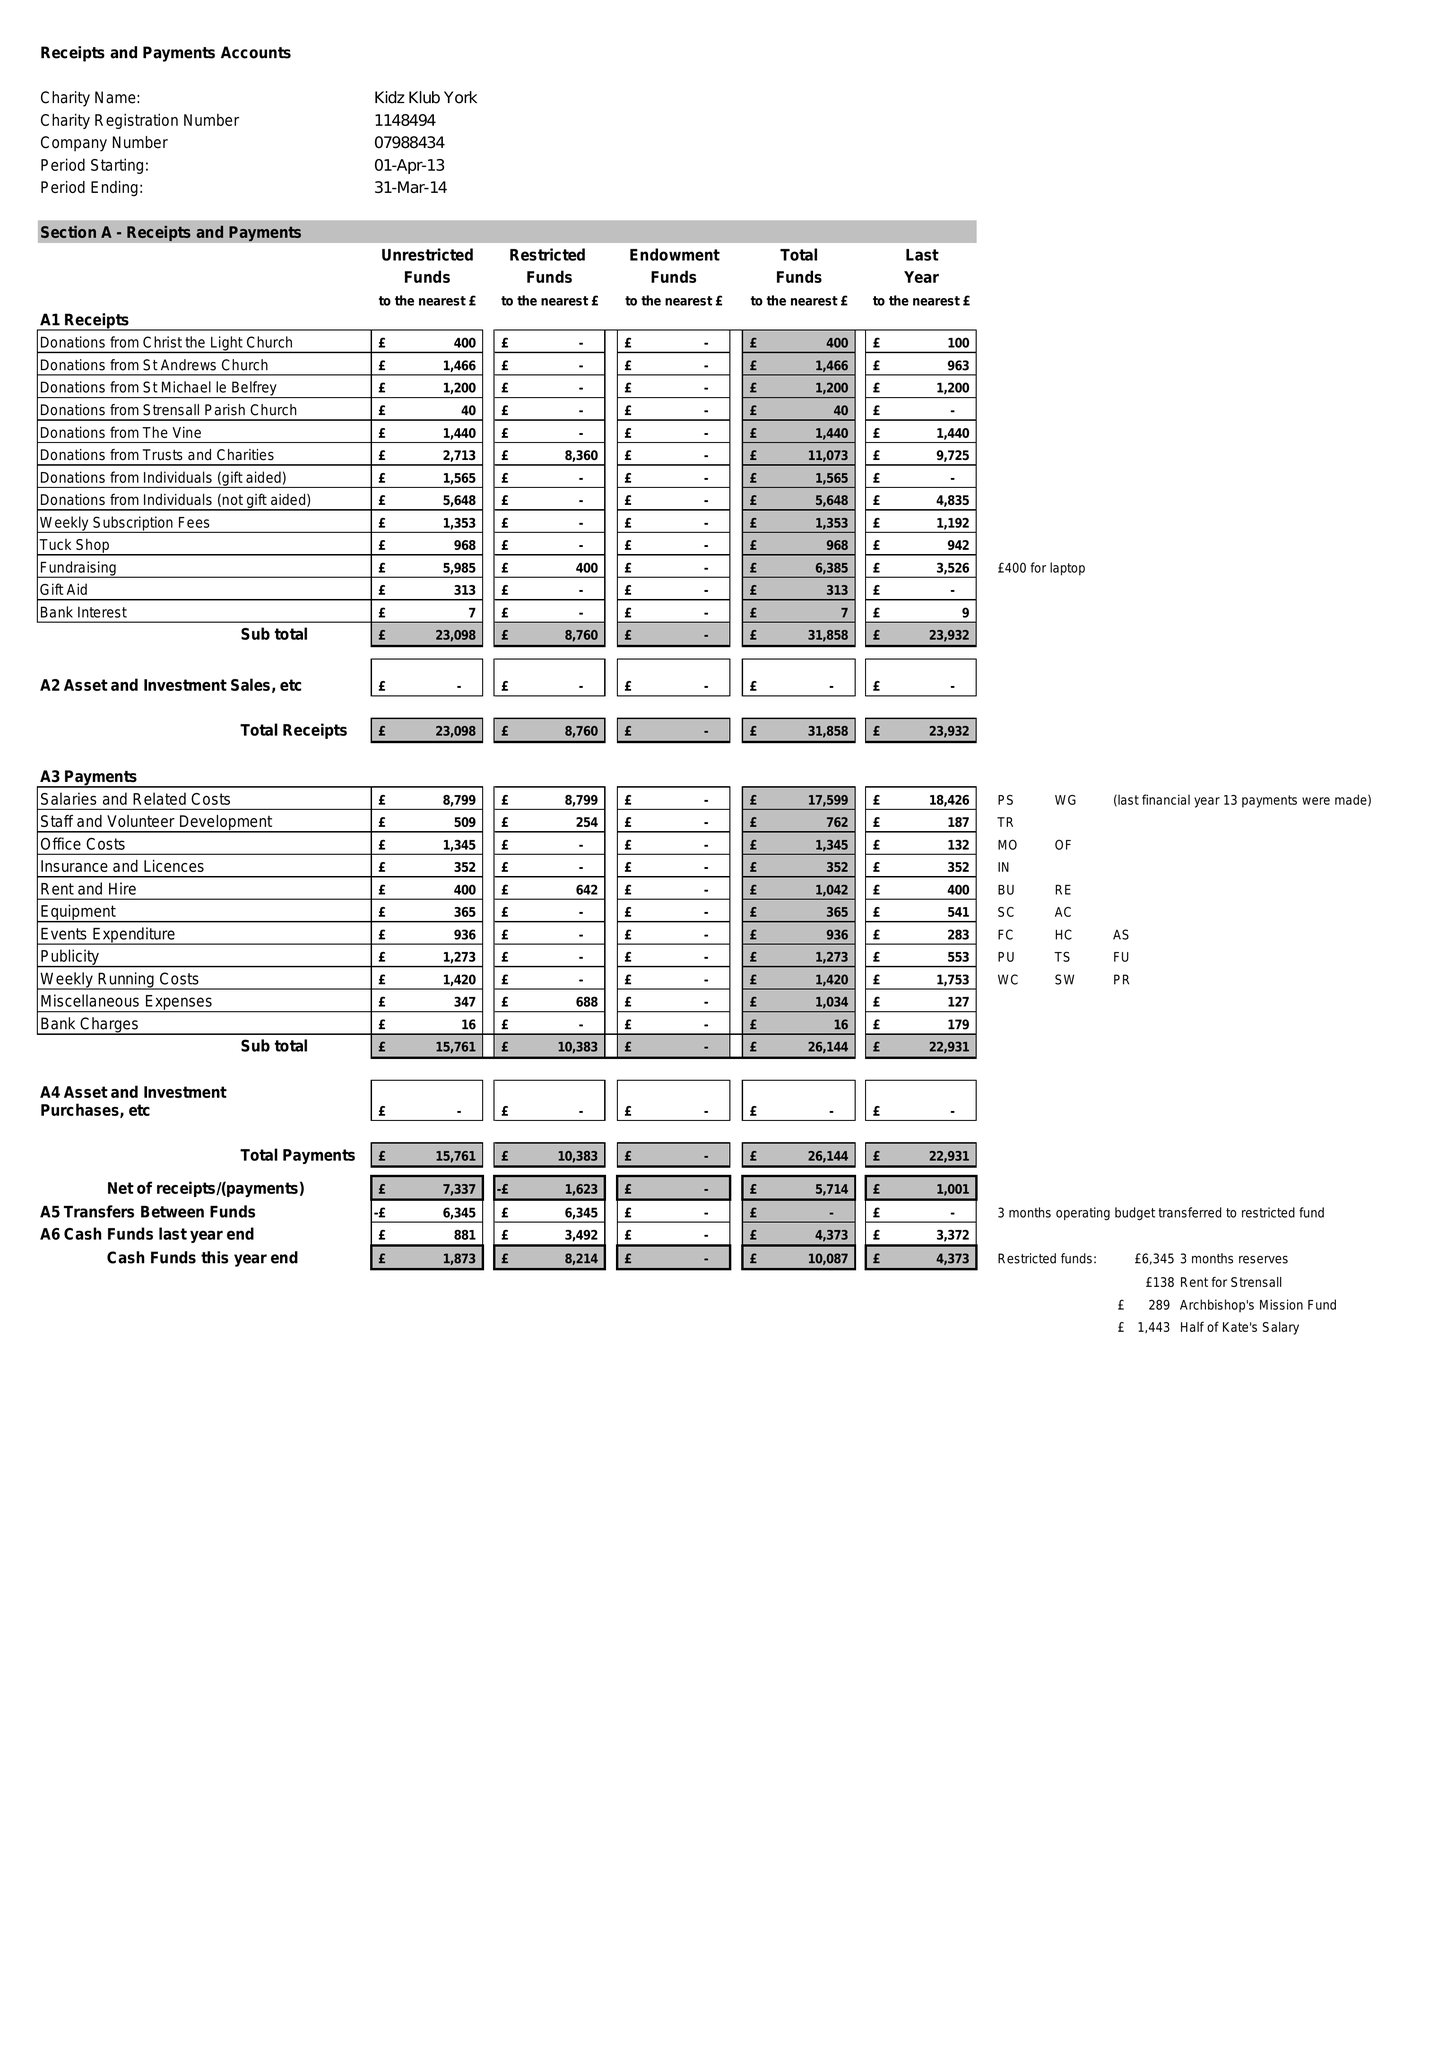What is the value for the charity_number?
Answer the question using a single word or phrase. 1148494 